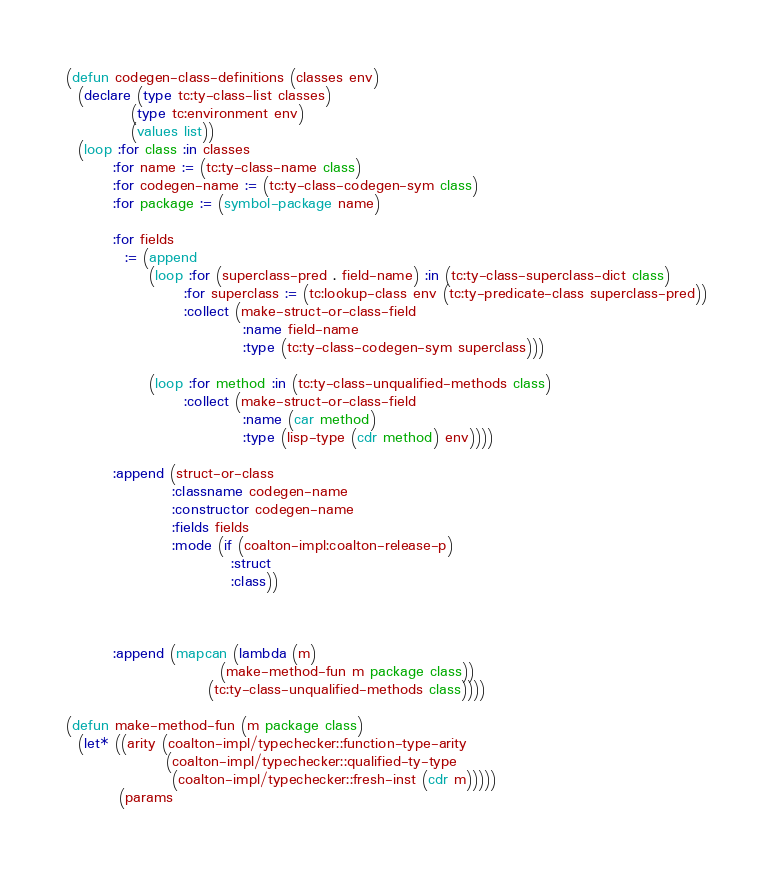Convert code to text. <code><loc_0><loc_0><loc_500><loc_500><_Lisp_>
(defun codegen-class-definitions (classes env)
  (declare (type tc:ty-class-list classes)
           (type tc:environment env)
           (values list))
  (loop :for class :in classes
        :for name := (tc:ty-class-name class)
        :for codegen-name := (tc:ty-class-codegen-sym class)
        :for package := (symbol-package name)

        :for fields
          := (append
              (loop :for (superclass-pred . field-name) :in (tc:ty-class-superclass-dict class)
                    :for superclass := (tc:lookup-class env (tc:ty-predicate-class superclass-pred))
                    :collect (make-struct-or-class-field
                              :name field-name
                              :type (tc:ty-class-codegen-sym superclass)))

              (loop :for method :in (tc:ty-class-unqualified-methods class)
                    :collect (make-struct-or-class-field
                              :name (car method)
                              :type (lisp-type (cdr method) env))))

        :append (struct-or-class
                  :classname codegen-name
                  :constructor codegen-name
                  :fields fields
                  :mode (if (coalton-impl:coalton-release-p)
                            :struct
                            :class))



        :append (mapcan (lambda (m)
                          (make-method-fun m package class))
                        (tc:ty-class-unqualified-methods class))))

(defun make-method-fun (m package class)
  (let* ((arity (coalton-impl/typechecker::function-type-arity
                 (coalton-impl/typechecker::qualified-ty-type
                  (coalton-impl/typechecker::fresh-inst (cdr m)))))
         (params</code> 